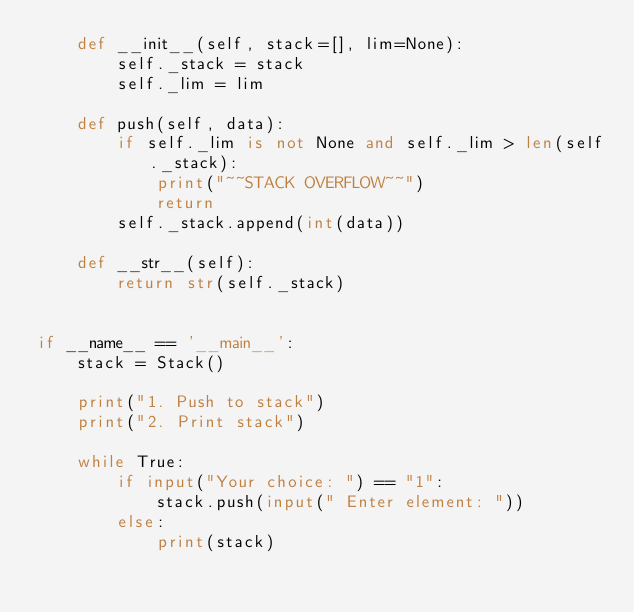<code> <loc_0><loc_0><loc_500><loc_500><_Python_>    def __init__(self, stack=[], lim=None):
        self._stack = stack
        self._lim = lim

    def push(self, data):
        if self._lim is not None and self._lim > len(self._stack):
            print("~~STACK OVERFLOW~~")
            return
        self._stack.append(int(data))

    def __str__(self):
        return str(self._stack)


if __name__ == '__main__':
    stack = Stack()

    print("1. Push to stack")
    print("2. Print stack")

    while True:
        if input("Your choice: ") == "1":
            stack.push(input(" Enter element: "))
        else:
            print(stack)
</code> 